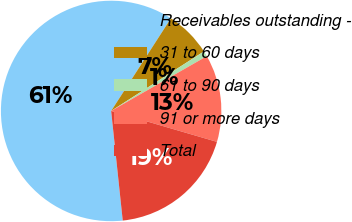<chart> <loc_0><loc_0><loc_500><loc_500><pie_chart><fcel>Receivables outstanding -<fcel>31 to 60 days<fcel>61 to 90 days<fcel>91 or more days<fcel>Total<nl><fcel>60.79%<fcel>6.8%<fcel>0.8%<fcel>12.8%<fcel>18.8%<nl></chart> 